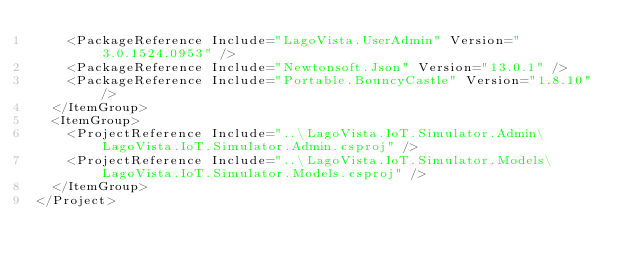Convert code to text. <code><loc_0><loc_0><loc_500><loc_500><_XML_>    <PackageReference Include="LagoVista.UserAdmin" Version="3.0.1524.0953" />
    <PackageReference Include="Newtonsoft.Json" Version="13.0.1" />
    <PackageReference Include="Portable.BouncyCastle" Version="1.8.10" />
  </ItemGroup>
  <ItemGroup>
    <ProjectReference Include="..\LagoVista.IoT.Simulator.Admin\LagoVista.IoT.Simulator.Admin.csproj" />
    <ProjectReference Include="..\LagoVista.IoT.Simulator.Models\LagoVista.IoT.Simulator.Models.csproj" />
  </ItemGroup>
</Project></code> 